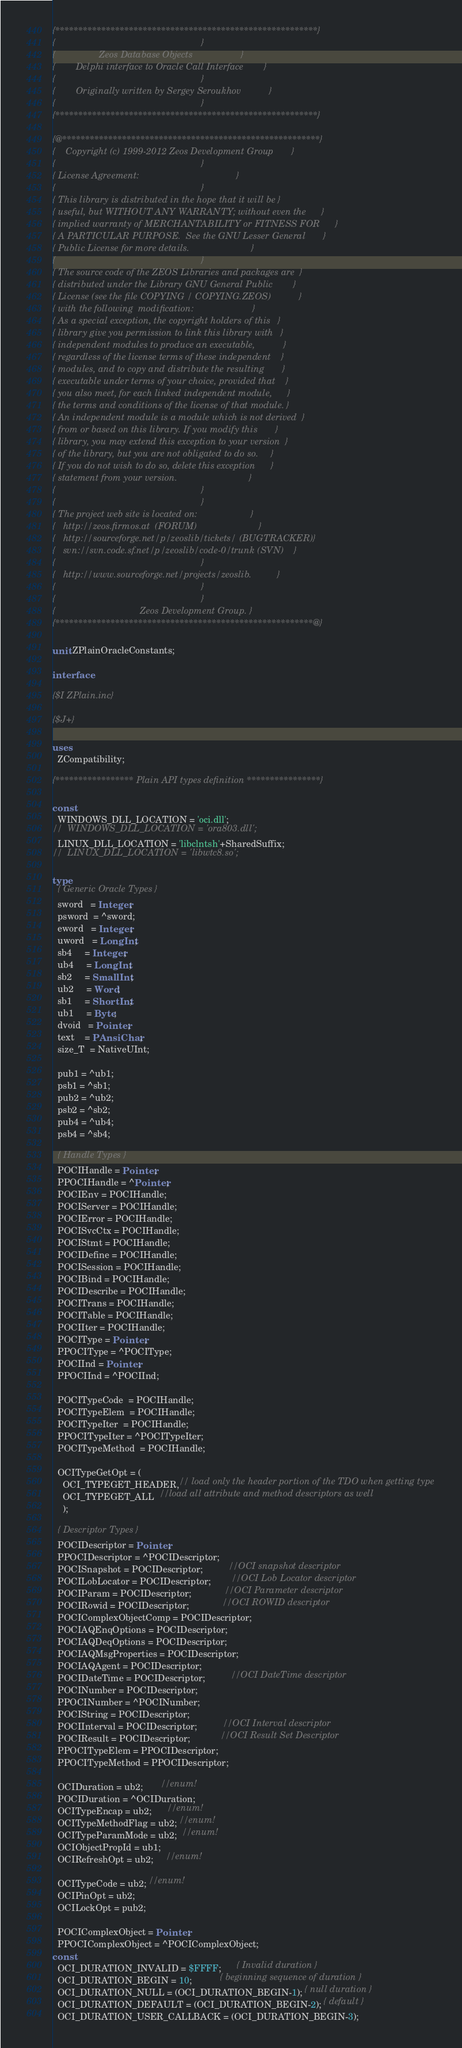<code> <loc_0><loc_0><loc_500><loc_500><_Pascal_>{*********************************************************}
{                                                         }
{                 Zeos Database Objects                   }
{        Delphi interface to Oracle Call Interface        }
{                                                         }
{        Originally written by Sergey Seroukhov           }
{                                                         }
{*********************************************************}

{@********************************************************}
{    Copyright (c) 1999-2012 Zeos Development Group       }
{                                                         }
{ License Agreement:                                      }
{                                                         }
{ This library is distributed in the hope that it will be }
{ useful, but WITHOUT ANY WARRANTY; without even the      }
{ implied warranty of MERCHANTABILITY or FITNESS FOR      }
{ A PARTICULAR PURPOSE.  See the GNU Lesser General       }
{ Public License for more details.                        }
{                                                         }
{ The source code of the ZEOS Libraries and packages are  }
{ distributed under the Library GNU General Public        }
{ License (see the file COPYING / COPYING.ZEOS)           }
{ with the following  modification:                       }
{ As a special exception, the copyright holders of this   }
{ library give you permission to link this library with   }
{ independent modules to produce an executable,           }
{ regardless of the license terms of these independent    }
{ modules, and to copy and distribute the resulting       }
{ executable under terms of your choice, provided that    }
{ you also meet, for each linked independent module,      }
{ the terms and conditions of the license of that module. }
{ An independent module is a module which is not derived  }
{ from or based on this library. If you modify this       }
{ library, you may extend this exception to your version  }
{ of the library, but you are not obligated to do so.     }
{ If you do not wish to do so, delete this exception      }
{ statement from your version.                            }
{                                                         }
{                                                         }
{ The project web site is located on:                     }
{   http://zeos.firmos.at  (FORUM)                        }
{   http://sourceforge.net/p/zeoslib/tickets/ (BUGTRACKER)}
{   svn://svn.code.sf.net/p/zeoslib/code-0/trunk (SVN)    }
{                                                         }
{   http://www.sourceforge.net/projects/zeoslib.          }
{                                                         }
{                                                         }
{                                 Zeos Development Group. }
{********************************************************@}

unit ZPlainOracleConstants;

interface

{$I ZPlain.inc}

{$J+}

uses
  ZCompatibility;

{***************** Plain API types definition ****************}

const
  WINDOWS_DLL_LOCATION = 'oci.dll';
//  WINDOWS_DLL_LOCATION = 'ora803.dll';
  LINUX_DLL_LOCATION = 'libclntsh'+SharedSuffix;
//  LINUX_DLL_LOCATION = 'libwtc8.so';

type
  { Generic Oracle Types }
  sword   = Integer;
  psword  = ^sword;
  eword   = Integer;
  uword   = LongInt;
  sb4     = Integer;
  ub4     = LongInt;
  sb2     = SmallInt;
  ub2     = Word;
  sb1     = ShortInt;
  ub1     = Byte;
  dvoid   = Pointer;
  text    = PAnsiChar;
  size_T  = NativeUInt;

  pub1 = ^ub1;
  psb1 = ^sb1;
  pub2 = ^ub2;
  psb2 = ^sb2;
  pub4 = ^ub4;
  psb4 = ^sb4;

  { Handle Types }
  POCIHandle = Pointer;
  PPOCIHandle = ^Pointer;
  POCIEnv = POCIHandle;
  POCIServer = POCIHandle;
  POCIError = POCIHandle;
  POCISvcCtx = POCIHandle;
  POCIStmt = POCIHandle;
  POCIDefine = POCIHandle;
  POCISession = POCIHandle;
  POCIBind = POCIHandle;
  POCIDescribe = POCIHandle;
  POCITrans = POCIHandle;
  POCITable = POCIHandle;
  POCIIter = POCIHandle;
  POCIType = Pointer;
  PPOCIType = ^POCIType;
  POCIInd = Pointer;
  PPOCIInd = ^POCIInd;

  POCITypeCode  = POCIHandle;
  POCITypeElem  = POCIHandle;
  POCITypeIter  = POCIHandle;
  PPOCITypeIter = ^POCITypeIter;
  POCITypeMethod  = POCIHandle;

  OCITypeGetOpt = (
    OCI_TYPEGET_HEADER,// load only the header portion of the TDO when getting type
    OCI_TYPEGET_ALL  //load all attribute and method descriptors as well
    );

  { Descriptor Types }
  POCIDescriptor = Pointer;
  PPOCIDescriptor = ^POCIDescriptor;
  POCISnapshot = POCIDescriptor;          //OCI snapshot descriptor
  POCILobLocator = POCIDescriptor;        //OCI Lob Locator descriptor
  POCIParam = POCIDescriptor;             //OCI Parameter descriptor
  POCIRowid = POCIDescriptor;             //OCI ROWID descriptor
  POCIComplexObjectComp = POCIDescriptor;
  POCIAQEnqOptions = POCIDescriptor;
  POCIAQDeqOptions = POCIDescriptor;
  POCIAQMsgProperties = POCIDescriptor;
  POCIAQAgent = POCIDescriptor;
  POCIDateTime = POCIDescriptor;          //OCI DateTime descriptor
  POCINumber = POCIDescriptor;
  PPOCINumber = ^POCINumber;
  POCIString = POCIDescriptor;
  POCIInterval = POCIDescriptor;          //OCI Interval descriptor
  POCIResult = POCIDescriptor;            //OCI Result Set Descriptor
  PPOCITypeElem = PPOCIDescriptor;
  PPOCITypeMethod = PPOCIDescriptor;

  OCIDuration = ub2;       //enum!
  POCIDuration = ^OCIDuration;
  OCITypeEncap = ub2;      //enum!
  OCITypeMethodFlag = ub2; //enum!
  OCITypeParamMode = ub2;  //enum!
  OCIObjectPropId = ub1;
  OCIRefreshOpt = ub2;     //enum!

  OCITypeCode = ub2; //enum!
  OCIPinOpt = ub2;
  OCILockOpt = pub2;

  POCIComplexObject = Pointer;
  PPOCIComplexObject = ^POCIComplexObject;
const
  OCI_DURATION_INVALID = $FFFF;      { Invalid duration }
  OCI_DURATION_BEGIN = 10;           { beginning sequence of duration }
  OCI_DURATION_NULL = (OCI_DURATION_BEGIN-1); { null duration }
  OCI_DURATION_DEFAULT = (OCI_DURATION_BEGIN-2); { default }
  OCI_DURATION_USER_CALLBACK = (OCI_DURATION_BEGIN-3);</code> 